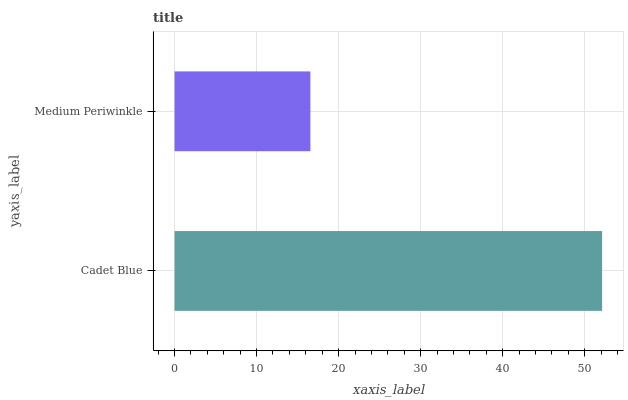Is Medium Periwinkle the minimum?
Answer yes or no. Yes. Is Cadet Blue the maximum?
Answer yes or no. Yes. Is Medium Periwinkle the maximum?
Answer yes or no. No. Is Cadet Blue greater than Medium Periwinkle?
Answer yes or no. Yes. Is Medium Periwinkle less than Cadet Blue?
Answer yes or no. Yes. Is Medium Periwinkle greater than Cadet Blue?
Answer yes or no. No. Is Cadet Blue less than Medium Periwinkle?
Answer yes or no. No. Is Cadet Blue the high median?
Answer yes or no. Yes. Is Medium Periwinkle the low median?
Answer yes or no. Yes. Is Medium Periwinkle the high median?
Answer yes or no. No. Is Cadet Blue the low median?
Answer yes or no. No. 